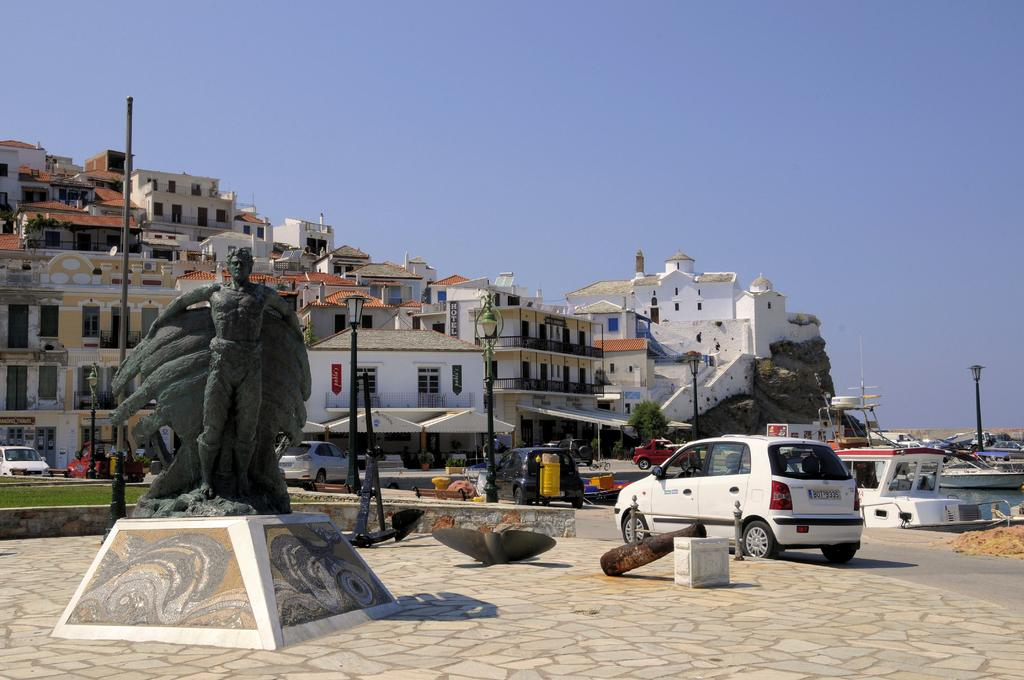Where was the image taken? The image was clicked outside. What can be seen on the left side of the image? There is a statue on the left side of the image. What is located in the middle of the image? There are buildings and a car in the middle of the image. What is visible at the top of the image? The sky is visible at the top of the image. What type of curve can be seen in the image? There is no curve present in the image. Can you describe the sidewalk in the image? There is no sidewalk present in the image. 